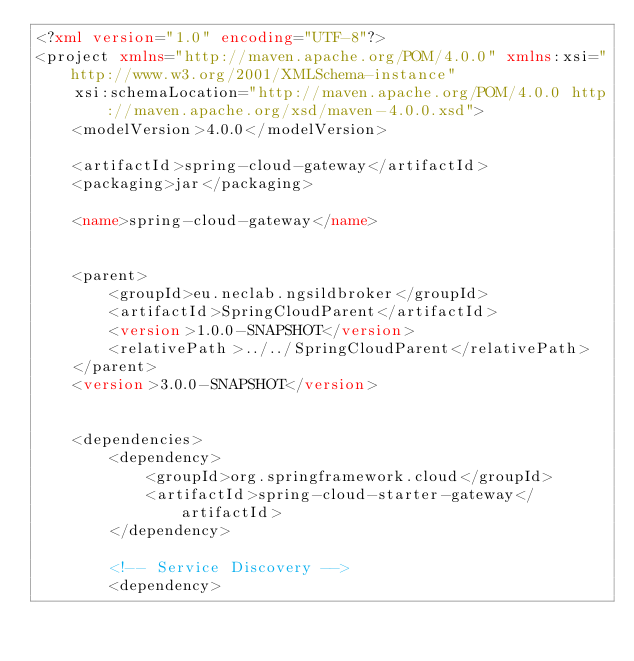Convert code to text. <code><loc_0><loc_0><loc_500><loc_500><_XML_><?xml version="1.0" encoding="UTF-8"?>
<project xmlns="http://maven.apache.org/POM/4.0.0" xmlns:xsi="http://www.w3.org/2001/XMLSchema-instance"
	xsi:schemaLocation="http://maven.apache.org/POM/4.0.0 http://maven.apache.org/xsd/maven-4.0.0.xsd">
	<modelVersion>4.0.0</modelVersion>

	<artifactId>spring-cloud-gateway</artifactId>
	<packaging>jar</packaging>

	<name>spring-cloud-gateway</name>


	<parent>
		<groupId>eu.neclab.ngsildbroker</groupId>
		<artifactId>SpringCloudParent</artifactId>
		<version>1.0.0-SNAPSHOT</version>
		<relativePath>../../SpringCloudParent</relativePath>
	</parent>
	<version>3.0.0-SNAPSHOT</version>


	<dependencies>
		<dependency>
			<groupId>org.springframework.cloud</groupId>
			<artifactId>spring-cloud-starter-gateway</artifactId>
		</dependency>

		<!-- Service Discovery -->
		<dependency></code> 